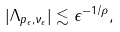Convert formula to latex. <formula><loc_0><loc_0><loc_500><loc_500>| \Lambda _ { p _ { \epsilon } , \nu _ { \epsilon } } | \lesssim \epsilon ^ { - 1 / \rho } ,</formula> 